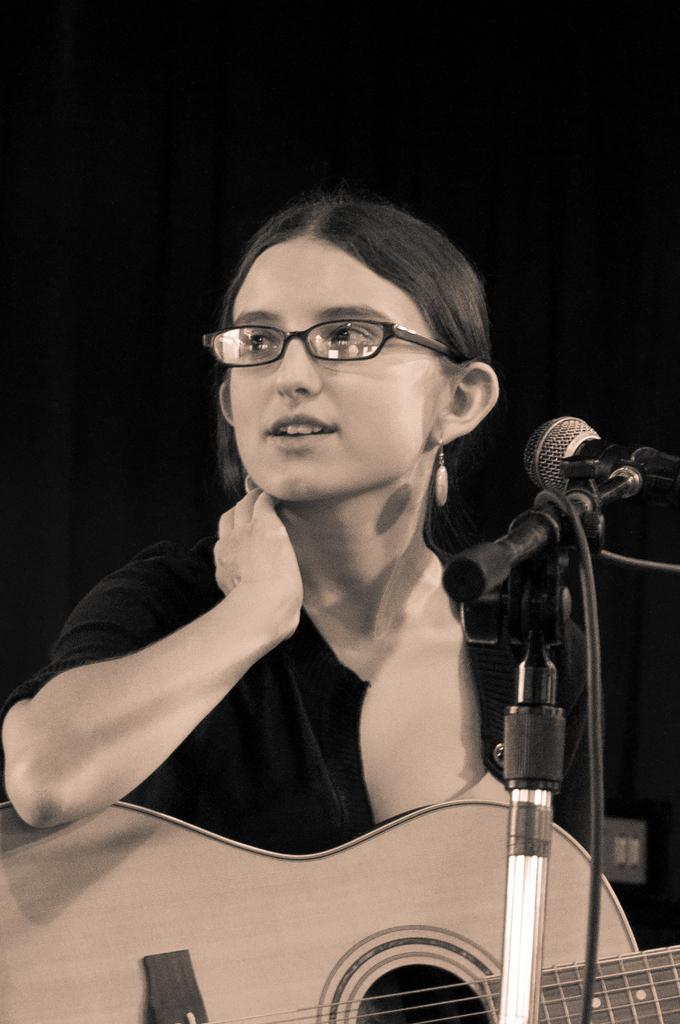How would you summarize this image in a sentence or two? In this image there is a lady person wearing black color dress and spectacles playing guitar and in front of her there is a microphone. 